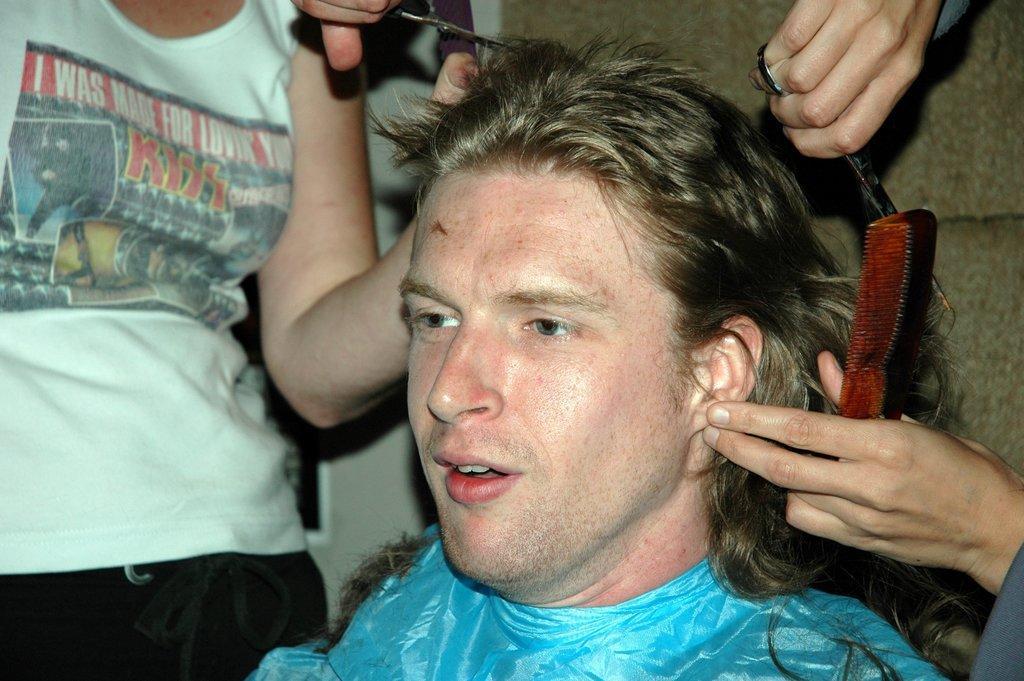How would you summarize this image in a sentence or two? In this picture there is a person sitting and there are two persons standing and holding the scissors. 